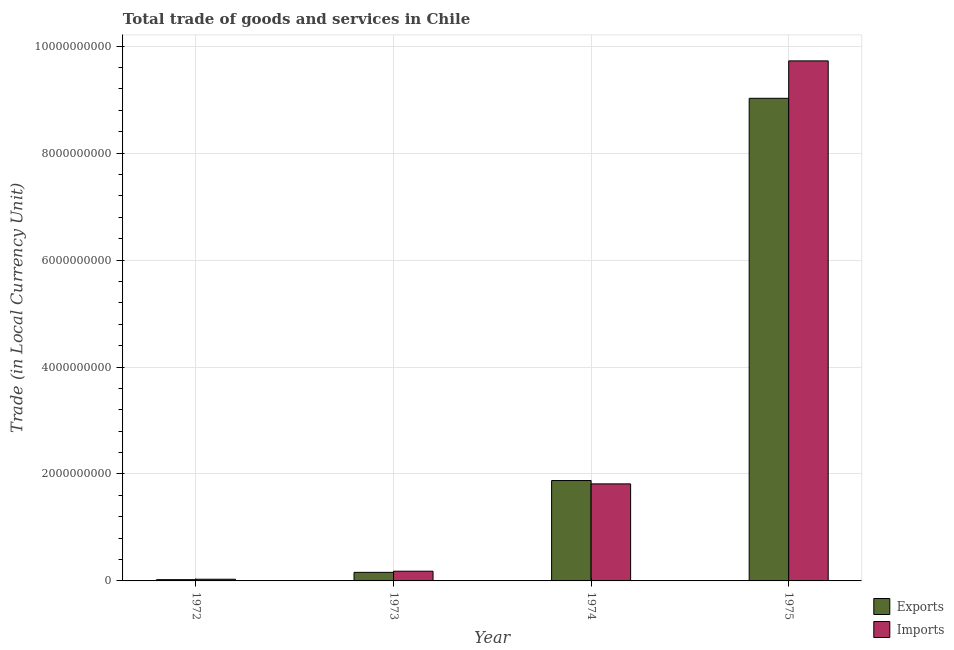How many different coloured bars are there?
Keep it short and to the point. 2. How many groups of bars are there?
Ensure brevity in your answer.  4. Are the number of bars per tick equal to the number of legend labels?
Offer a terse response. Yes. How many bars are there on the 3rd tick from the left?
Offer a very short reply. 2. How many bars are there on the 3rd tick from the right?
Make the answer very short. 2. What is the label of the 1st group of bars from the left?
Your answer should be compact. 1972. What is the export of goods and services in 1974?
Provide a short and direct response. 1.88e+09. Across all years, what is the maximum export of goods and services?
Provide a succinct answer. 9.03e+09. Across all years, what is the minimum export of goods and services?
Your answer should be very brief. 2.36e+07. In which year was the export of goods and services maximum?
Make the answer very short. 1975. What is the total export of goods and services in the graph?
Offer a terse response. 1.11e+1. What is the difference between the imports of goods and services in 1973 and that in 1975?
Offer a terse response. -9.54e+09. What is the difference between the export of goods and services in 1975 and the imports of goods and services in 1974?
Provide a succinct answer. 7.15e+09. What is the average export of goods and services per year?
Keep it short and to the point. 2.77e+09. In the year 1973, what is the difference between the export of goods and services and imports of goods and services?
Provide a succinct answer. 0. What is the ratio of the imports of goods and services in 1972 to that in 1974?
Your answer should be compact. 0.02. What is the difference between the highest and the second highest export of goods and services?
Your answer should be compact. 7.15e+09. What is the difference between the highest and the lowest imports of goods and services?
Make the answer very short. 9.69e+09. Is the sum of the export of goods and services in 1973 and 1974 greater than the maximum imports of goods and services across all years?
Offer a terse response. No. What does the 2nd bar from the left in 1975 represents?
Provide a short and direct response. Imports. What does the 2nd bar from the right in 1972 represents?
Your response must be concise. Exports. Are all the bars in the graph horizontal?
Offer a very short reply. No. What is the difference between two consecutive major ticks on the Y-axis?
Provide a short and direct response. 2.00e+09. Are the values on the major ticks of Y-axis written in scientific E-notation?
Ensure brevity in your answer.  No. Does the graph contain grids?
Provide a short and direct response. Yes. Where does the legend appear in the graph?
Your response must be concise. Bottom right. How many legend labels are there?
Offer a terse response. 2. What is the title of the graph?
Make the answer very short. Total trade of goods and services in Chile. Does "Merchandise exports" appear as one of the legend labels in the graph?
Make the answer very short. No. What is the label or title of the X-axis?
Give a very brief answer. Year. What is the label or title of the Y-axis?
Provide a short and direct response. Trade (in Local Currency Unit). What is the Trade (in Local Currency Unit) in Exports in 1972?
Give a very brief answer. 2.36e+07. What is the Trade (in Local Currency Unit) of Imports in 1972?
Ensure brevity in your answer.  3.18e+07. What is the Trade (in Local Currency Unit) of Exports in 1973?
Ensure brevity in your answer.  1.60e+08. What is the Trade (in Local Currency Unit) of Imports in 1973?
Offer a terse response. 1.82e+08. What is the Trade (in Local Currency Unit) in Exports in 1974?
Offer a very short reply. 1.88e+09. What is the Trade (in Local Currency Unit) of Imports in 1974?
Make the answer very short. 1.81e+09. What is the Trade (in Local Currency Unit) in Exports in 1975?
Offer a very short reply. 9.03e+09. What is the Trade (in Local Currency Unit) of Imports in 1975?
Make the answer very short. 9.73e+09. Across all years, what is the maximum Trade (in Local Currency Unit) in Exports?
Offer a very short reply. 9.03e+09. Across all years, what is the maximum Trade (in Local Currency Unit) in Imports?
Your answer should be compact. 9.73e+09. Across all years, what is the minimum Trade (in Local Currency Unit) in Exports?
Offer a terse response. 2.36e+07. Across all years, what is the minimum Trade (in Local Currency Unit) of Imports?
Ensure brevity in your answer.  3.18e+07. What is the total Trade (in Local Currency Unit) in Exports in the graph?
Keep it short and to the point. 1.11e+1. What is the total Trade (in Local Currency Unit) in Imports in the graph?
Ensure brevity in your answer.  1.18e+1. What is the difference between the Trade (in Local Currency Unit) of Exports in 1972 and that in 1973?
Offer a terse response. -1.37e+08. What is the difference between the Trade (in Local Currency Unit) of Imports in 1972 and that in 1973?
Provide a short and direct response. -1.50e+08. What is the difference between the Trade (in Local Currency Unit) of Exports in 1972 and that in 1974?
Your response must be concise. -1.85e+09. What is the difference between the Trade (in Local Currency Unit) of Imports in 1972 and that in 1974?
Offer a very short reply. -1.78e+09. What is the difference between the Trade (in Local Currency Unit) in Exports in 1972 and that in 1975?
Keep it short and to the point. -9.00e+09. What is the difference between the Trade (in Local Currency Unit) in Imports in 1972 and that in 1975?
Your answer should be very brief. -9.69e+09. What is the difference between the Trade (in Local Currency Unit) in Exports in 1973 and that in 1974?
Your response must be concise. -1.72e+09. What is the difference between the Trade (in Local Currency Unit) of Imports in 1973 and that in 1974?
Provide a succinct answer. -1.63e+09. What is the difference between the Trade (in Local Currency Unit) of Exports in 1973 and that in 1975?
Your response must be concise. -8.87e+09. What is the difference between the Trade (in Local Currency Unit) of Imports in 1973 and that in 1975?
Give a very brief answer. -9.54e+09. What is the difference between the Trade (in Local Currency Unit) in Exports in 1974 and that in 1975?
Make the answer very short. -7.15e+09. What is the difference between the Trade (in Local Currency Unit) of Imports in 1974 and that in 1975?
Provide a short and direct response. -7.91e+09. What is the difference between the Trade (in Local Currency Unit) of Exports in 1972 and the Trade (in Local Currency Unit) of Imports in 1973?
Provide a short and direct response. -1.58e+08. What is the difference between the Trade (in Local Currency Unit) in Exports in 1972 and the Trade (in Local Currency Unit) in Imports in 1974?
Your answer should be compact. -1.79e+09. What is the difference between the Trade (in Local Currency Unit) in Exports in 1972 and the Trade (in Local Currency Unit) in Imports in 1975?
Give a very brief answer. -9.70e+09. What is the difference between the Trade (in Local Currency Unit) in Exports in 1973 and the Trade (in Local Currency Unit) in Imports in 1974?
Give a very brief answer. -1.65e+09. What is the difference between the Trade (in Local Currency Unit) of Exports in 1973 and the Trade (in Local Currency Unit) of Imports in 1975?
Keep it short and to the point. -9.57e+09. What is the difference between the Trade (in Local Currency Unit) of Exports in 1974 and the Trade (in Local Currency Unit) of Imports in 1975?
Your answer should be very brief. -7.85e+09. What is the average Trade (in Local Currency Unit) in Exports per year?
Provide a succinct answer. 2.77e+09. What is the average Trade (in Local Currency Unit) of Imports per year?
Give a very brief answer. 2.94e+09. In the year 1972, what is the difference between the Trade (in Local Currency Unit) of Exports and Trade (in Local Currency Unit) of Imports?
Your answer should be compact. -8.20e+06. In the year 1973, what is the difference between the Trade (in Local Currency Unit) of Exports and Trade (in Local Currency Unit) of Imports?
Make the answer very short. -2.13e+07. In the year 1974, what is the difference between the Trade (in Local Currency Unit) in Exports and Trade (in Local Currency Unit) in Imports?
Your answer should be compact. 6.23e+07. In the year 1975, what is the difference between the Trade (in Local Currency Unit) of Exports and Trade (in Local Currency Unit) of Imports?
Your answer should be compact. -7.00e+08. What is the ratio of the Trade (in Local Currency Unit) in Exports in 1972 to that in 1973?
Make the answer very short. 0.15. What is the ratio of the Trade (in Local Currency Unit) in Imports in 1972 to that in 1973?
Offer a very short reply. 0.18. What is the ratio of the Trade (in Local Currency Unit) in Exports in 1972 to that in 1974?
Your answer should be very brief. 0.01. What is the ratio of the Trade (in Local Currency Unit) of Imports in 1972 to that in 1974?
Offer a very short reply. 0.02. What is the ratio of the Trade (in Local Currency Unit) of Exports in 1972 to that in 1975?
Provide a succinct answer. 0. What is the ratio of the Trade (in Local Currency Unit) of Imports in 1972 to that in 1975?
Your answer should be compact. 0. What is the ratio of the Trade (in Local Currency Unit) of Exports in 1973 to that in 1974?
Your answer should be compact. 0.09. What is the ratio of the Trade (in Local Currency Unit) in Imports in 1973 to that in 1974?
Keep it short and to the point. 0.1. What is the ratio of the Trade (in Local Currency Unit) in Exports in 1973 to that in 1975?
Your answer should be very brief. 0.02. What is the ratio of the Trade (in Local Currency Unit) of Imports in 1973 to that in 1975?
Keep it short and to the point. 0.02. What is the ratio of the Trade (in Local Currency Unit) of Exports in 1974 to that in 1975?
Make the answer very short. 0.21. What is the ratio of the Trade (in Local Currency Unit) in Imports in 1974 to that in 1975?
Offer a terse response. 0.19. What is the difference between the highest and the second highest Trade (in Local Currency Unit) of Exports?
Offer a very short reply. 7.15e+09. What is the difference between the highest and the second highest Trade (in Local Currency Unit) in Imports?
Provide a short and direct response. 7.91e+09. What is the difference between the highest and the lowest Trade (in Local Currency Unit) of Exports?
Make the answer very short. 9.00e+09. What is the difference between the highest and the lowest Trade (in Local Currency Unit) in Imports?
Ensure brevity in your answer.  9.69e+09. 